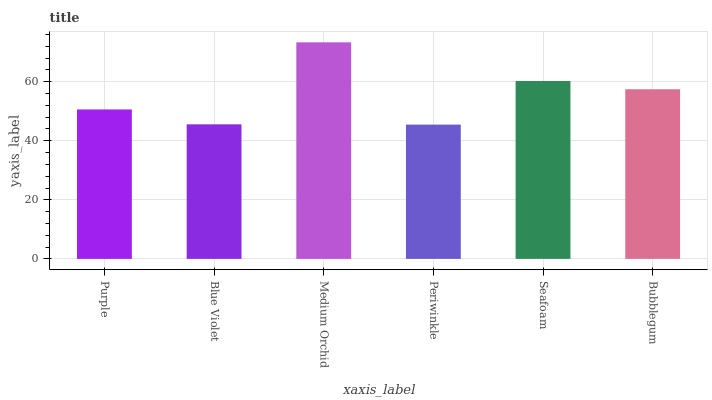Is Periwinkle the minimum?
Answer yes or no. Yes. Is Medium Orchid the maximum?
Answer yes or no. Yes. Is Blue Violet the minimum?
Answer yes or no. No. Is Blue Violet the maximum?
Answer yes or no. No. Is Purple greater than Blue Violet?
Answer yes or no. Yes. Is Blue Violet less than Purple?
Answer yes or no. Yes. Is Blue Violet greater than Purple?
Answer yes or no. No. Is Purple less than Blue Violet?
Answer yes or no. No. Is Bubblegum the high median?
Answer yes or no. Yes. Is Purple the low median?
Answer yes or no. Yes. Is Seafoam the high median?
Answer yes or no. No. Is Medium Orchid the low median?
Answer yes or no. No. 